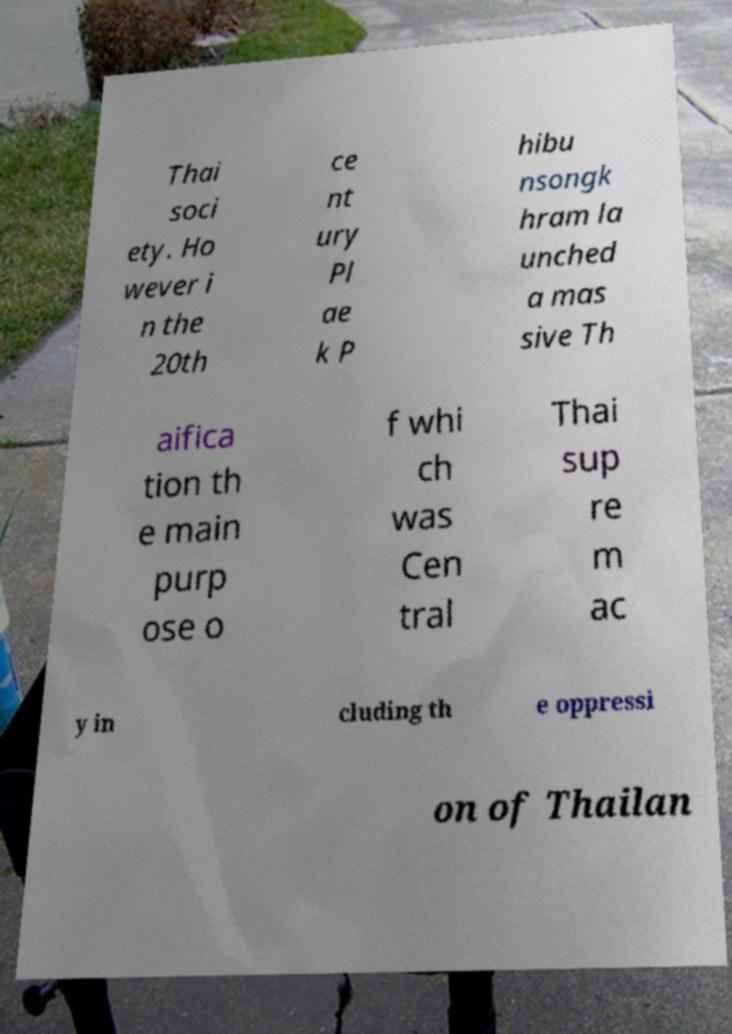Could you extract and type out the text from this image? Thai soci ety. Ho wever i n the 20th ce nt ury Pl ae k P hibu nsongk hram la unched a mas sive Th aifica tion th e main purp ose o f whi ch was Cen tral Thai sup re m ac y in cluding th e oppressi on of Thailan 